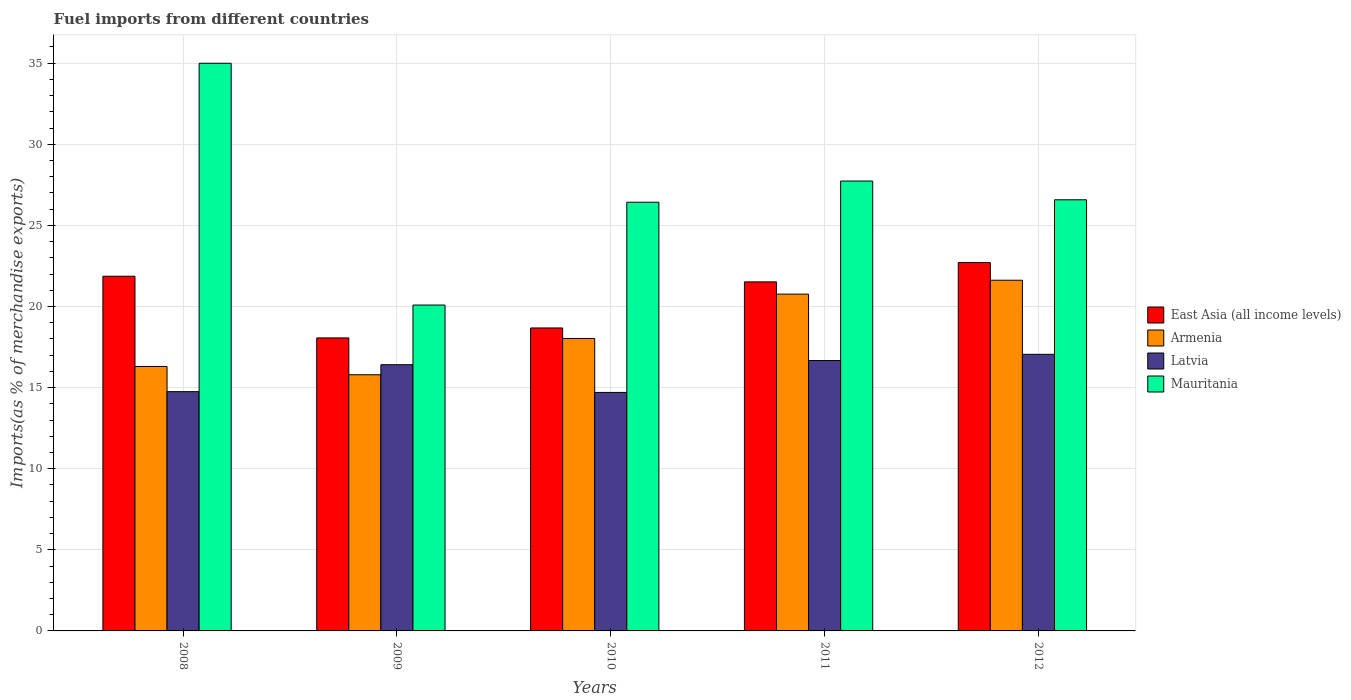How many different coloured bars are there?
Provide a succinct answer. 4. How many bars are there on the 3rd tick from the left?
Your answer should be compact. 4. What is the label of the 4th group of bars from the left?
Your answer should be very brief. 2011. What is the percentage of imports to different countries in Armenia in 2010?
Provide a short and direct response. 18.03. Across all years, what is the maximum percentage of imports to different countries in Latvia?
Your response must be concise. 17.05. Across all years, what is the minimum percentage of imports to different countries in Latvia?
Offer a very short reply. 14.7. In which year was the percentage of imports to different countries in Armenia minimum?
Ensure brevity in your answer.  2009. What is the total percentage of imports to different countries in Latvia in the graph?
Give a very brief answer. 79.58. What is the difference between the percentage of imports to different countries in Armenia in 2008 and that in 2011?
Offer a terse response. -4.46. What is the difference between the percentage of imports to different countries in Latvia in 2010 and the percentage of imports to different countries in Mauritania in 2012?
Offer a terse response. -11.87. What is the average percentage of imports to different countries in Latvia per year?
Your answer should be compact. 15.92. In the year 2012, what is the difference between the percentage of imports to different countries in Mauritania and percentage of imports to different countries in Armenia?
Provide a short and direct response. 4.96. What is the ratio of the percentage of imports to different countries in Latvia in 2009 to that in 2012?
Your answer should be compact. 0.96. Is the percentage of imports to different countries in East Asia (all income levels) in 2010 less than that in 2011?
Your answer should be compact. Yes. Is the difference between the percentage of imports to different countries in Mauritania in 2009 and 2010 greater than the difference between the percentage of imports to different countries in Armenia in 2009 and 2010?
Offer a terse response. No. What is the difference between the highest and the second highest percentage of imports to different countries in Latvia?
Your response must be concise. 0.39. What is the difference between the highest and the lowest percentage of imports to different countries in Armenia?
Make the answer very short. 5.83. Is the sum of the percentage of imports to different countries in Armenia in 2011 and 2012 greater than the maximum percentage of imports to different countries in Mauritania across all years?
Ensure brevity in your answer.  Yes. What does the 4th bar from the left in 2008 represents?
Offer a terse response. Mauritania. What does the 3rd bar from the right in 2012 represents?
Offer a very short reply. Armenia. Are all the bars in the graph horizontal?
Your answer should be compact. No. How many years are there in the graph?
Your response must be concise. 5. What is the difference between two consecutive major ticks on the Y-axis?
Offer a very short reply. 5. Are the values on the major ticks of Y-axis written in scientific E-notation?
Offer a very short reply. No. Does the graph contain any zero values?
Your response must be concise. No. How are the legend labels stacked?
Offer a terse response. Vertical. What is the title of the graph?
Your answer should be compact. Fuel imports from different countries. What is the label or title of the X-axis?
Your response must be concise. Years. What is the label or title of the Y-axis?
Provide a succinct answer. Imports(as % of merchandise exports). What is the Imports(as % of merchandise exports) of East Asia (all income levels) in 2008?
Keep it short and to the point. 21.87. What is the Imports(as % of merchandise exports) of Armenia in 2008?
Your answer should be compact. 16.3. What is the Imports(as % of merchandise exports) in Latvia in 2008?
Provide a succinct answer. 14.75. What is the Imports(as % of merchandise exports) of Mauritania in 2008?
Your answer should be very brief. 34.99. What is the Imports(as % of merchandise exports) of East Asia (all income levels) in 2009?
Offer a very short reply. 18.06. What is the Imports(as % of merchandise exports) of Armenia in 2009?
Your response must be concise. 15.79. What is the Imports(as % of merchandise exports) of Latvia in 2009?
Make the answer very short. 16.41. What is the Imports(as % of merchandise exports) in Mauritania in 2009?
Your answer should be very brief. 20.09. What is the Imports(as % of merchandise exports) in East Asia (all income levels) in 2010?
Keep it short and to the point. 18.68. What is the Imports(as % of merchandise exports) in Armenia in 2010?
Offer a terse response. 18.03. What is the Imports(as % of merchandise exports) of Latvia in 2010?
Make the answer very short. 14.7. What is the Imports(as % of merchandise exports) in Mauritania in 2010?
Offer a terse response. 26.43. What is the Imports(as % of merchandise exports) of East Asia (all income levels) in 2011?
Keep it short and to the point. 21.52. What is the Imports(as % of merchandise exports) in Armenia in 2011?
Provide a short and direct response. 20.76. What is the Imports(as % of merchandise exports) of Latvia in 2011?
Ensure brevity in your answer.  16.67. What is the Imports(as % of merchandise exports) of Mauritania in 2011?
Your answer should be compact. 27.73. What is the Imports(as % of merchandise exports) of East Asia (all income levels) in 2012?
Keep it short and to the point. 22.71. What is the Imports(as % of merchandise exports) of Armenia in 2012?
Your response must be concise. 21.62. What is the Imports(as % of merchandise exports) of Latvia in 2012?
Keep it short and to the point. 17.05. What is the Imports(as % of merchandise exports) in Mauritania in 2012?
Provide a short and direct response. 26.58. Across all years, what is the maximum Imports(as % of merchandise exports) in East Asia (all income levels)?
Make the answer very short. 22.71. Across all years, what is the maximum Imports(as % of merchandise exports) in Armenia?
Keep it short and to the point. 21.62. Across all years, what is the maximum Imports(as % of merchandise exports) of Latvia?
Offer a terse response. 17.05. Across all years, what is the maximum Imports(as % of merchandise exports) of Mauritania?
Your answer should be very brief. 34.99. Across all years, what is the minimum Imports(as % of merchandise exports) of East Asia (all income levels)?
Provide a short and direct response. 18.06. Across all years, what is the minimum Imports(as % of merchandise exports) of Armenia?
Keep it short and to the point. 15.79. Across all years, what is the minimum Imports(as % of merchandise exports) in Latvia?
Provide a short and direct response. 14.7. Across all years, what is the minimum Imports(as % of merchandise exports) of Mauritania?
Your response must be concise. 20.09. What is the total Imports(as % of merchandise exports) in East Asia (all income levels) in the graph?
Your answer should be very brief. 102.83. What is the total Imports(as % of merchandise exports) of Armenia in the graph?
Your answer should be compact. 92.5. What is the total Imports(as % of merchandise exports) in Latvia in the graph?
Your answer should be very brief. 79.58. What is the total Imports(as % of merchandise exports) in Mauritania in the graph?
Make the answer very short. 135.82. What is the difference between the Imports(as % of merchandise exports) in East Asia (all income levels) in 2008 and that in 2009?
Provide a short and direct response. 3.8. What is the difference between the Imports(as % of merchandise exports) of Armenia in 2008 and that in 2009?
Offer a terse response. 0.51. What is the difference between the Imports(as % of merchandise exports) in Latvia in 2008 and that in 2009?
Give a very brief answer. -1.66. What is the difference between the Imports(as % of merchandise exports) in Mauritania in 2008 and that in 2009?
Your answer should be very brief. 14.9. What is the difference between the Imports(as % of merchandise exports) in East Asia (all income levels) in 2008 and that in 2010?
Your answer should be compact. 3.19. What is the difference between the Imports(as % of merchandise exports) in Armenia in 2008 and that in 2010?
Give a very brief answer. -1.73. What is the difference between the Imports(as % of merchandise exports) of Latvia in 2008 and that in 2010?
Your answer should be compact. 0.05. What is the difference between the Imports(as % of merchandise exports) of Mauritania in 2008 and that in 2010?
Your answer should be compact. 8.57. What is the difference between the Imports(as % of merchandise exports) of East Asia (all income levels) in 2008 and that in 2011?
Make the answer very short. 0.35. What is the difference between the Imports(as % of merchandise exports) of Armenia in 2008 and that in 2011?
Give a very brief answer. -4.46. What is the difference between the Imports(as % of merchandise exports) in Latvia in 2008 and that in 2011?
Your answer should be very brief. -1.92. What is the difference between the Imports(as % of merchandise exports) of Mauritania in 2008 and that in 2011?
Ensure brevity in your answer.  7.26. What is the difference between the Imports(as % of merchandise exports) of East Asia (all income levels) in 2008 and that in 2012?
Provide a short and direct response. -0.84. What is the difference between the Imports(as % of merchandise exports) of Armenia in 2008 and that in 2012?
Your answer should be very brief. -5.32. What is the difference between the Imports(as % of merchandise exports) in Latvia in 2008 and that in 2012?
Keep it short and to the point. -2.3. What is the difference between the Imports(as % of merchandise exports) of Mauritania in 2008 and that in 2012?
Provide a short and direct response. 8.42. What is the difference between the Imports(as % of merchandise exports) in East Asia (all income levels) in 2009 and that in 2010?
Keep it short and to the point. -0.61. What is the difference between the Imports(as % of merchandise exports) in Armenia in 2009 and that in 2010?
Ensure brevity in your answer.  -2.24. What is the difference between the Imports(as % of merchandise exports) in Latvia in 2009 and that in 2010?
Keep it short and to the point. 1.71. What is the difference between the Imports(as % of merchandise exports) in Mauritania in 2009 and that in 2010?
Ensure brevity in your answer.  -6.34. What is the difference between the Imports(as % of merchandise exports) of East Asia (all income levels) in 2009 and that in 2011?
Give a very brief answer. -3.45. What is the difference between the Imports(as % of merchandise exports) of Armenia in 2009 and that in 2011?
Make the answer very short. -4.97. What is the difference between the Imports(as % of merchandise exports) in Latvia in 2009 and that in 2011?
Ensure brevity in your answer.  -0.26. What is the difference between the Imports(as % of merchandise exports) in Mauritania in 2009 and that in 2011?
Offer a terse response. -7.64. What is the difference between the Imports(as % of merchandise exports) of East Asia (all income levels) in 2009 and that in 2012?
Provide a short and direct response. -4.64. What is the difference between the Imports(as % of merchandise exports) in Armenia in 2009 and that in 2012?
Your response must be concise. -5.83. What is the difference between the Imports(as % of merchandise exports) in Latvia in 2009 and that in 2012?
Provide a succinct answer. -0.64. What is the difference between the Imports(as % of merchandise exports) of Mauritania in 2009 and that in 2012?
Ensure brevity in your answer.  -6.49. What is the difference between the Imports(as % of merchandise exports) of East Asia (all income levels) in 2010 and that in 2011?
Ensure brevity in your answer.  -2.84. What is the difference between the Imports(as % of merchandise exports) of Armenia in 2010 and that in 2011?
Make the answer very short. -2.73. What is the difference between the Imports(as % of merchandise exports) of Latvia in 2010 and that in 2011?
Make the answer very short. -1.96. What is the difference between the Imports(as % of merchandise exports) of Mauritania in 2010 and that in 2011?
Offer a terse response. -1.31. What is the difference between the Imports(as % of merchandise exports) in East Asia (all income levels) in 2010 and that in 2012?
Your answer should be very brief. -4.03. What is the difference between the Imports(as % of merchandise exports) of Armenia in 2010 and that in 2012?
Your answer should be very brief. -3.59. What is the difference between the Imports(as % of merchandise exports) in Latvia in 2010 and that in 2012?
Make the answer very short. -2.35. What is the difference between the Imports(as % of merchandise exports) in Mauritania in 2010 and that in 2012?
Ensure brevity in your answer.  -0.15. What is the difference between the Imports(as % of merchandise exports) in East Asia (all income levels) in 2011 and that in 2012?
Provide a short and direct response. -1.19. What is the difference between the Imports(as % of merchandise exports) in Armenia in 2011 and that in 2012?
Make the answer very short. -0.86. What is the difference between the Imports(as % of merchandise exports) in Latvia in 2011 and that in 2012?
Offer a terse response. -0.39. What is the difference between the Imports(as % of merchandise exports) in Mauritania in 2011 and that in 2012?
Offer a very short reply. 1.16. What is the difference between the Imports(as % of merchandise exports) of East Asia (all income levels) in 2008 and the Imports(as % of merchandise exports) of Armenia in 2009?
Give a very brief answer. 6.07. What is the difference between the Imports(as % of merchandise exports) of East Asia (all income levels) in 2008 and the Imports(as % of merchandise exports) of Latvia in 2009?
Provide a short and direct response. 5.45. What is the difference between the Imports(as % of merchandise exports) of East Asia (all income levels) in 2008 and the Imports(as % of merchandise exports) of Mauritania in 2009?
Your answer should be very brief. 1.78. What is the difference between the Imports(as % of merchandise exports) in Armenia in 2008 and the Imports(as % of merchandise exports) in Latvia in 2009?
Keep it short and to the point. -0.11. What is the difference between the Imports(as % of merchandise exports) of Armenia in 2008 and the Imports(as % of merchandise exports) of Mauritania in 2009?
Offer a terse response. -3.79. What is the difference between the Imports(as % of merchandise exports) of Latvia in 2008 and the Imports(as % of merchandise exports) of Mauritania in 2009?
Offer a terse response. -5.34. What is the difference between the Imports(as % of merchandise exports) of East Asia (all income levels) in 2008 and the Imports(as % of merchandise exports) of Armenia in 2010?
Offer a very short reply. 3.84. What is the difference between the Imports(as % of merchandise exports) in East Asia (all income levels) in 2008 and the Imports(as % of merchandise exports) in Latvia in 2010?
Your answer should be compact. 7.16. What is the difference between the Imports(as % of merchandise exports) in East Asia (all income levels) in 2008 and the Imports(as % of merchandise exports) in Mauritania in 2010?
Provide a succinct answer. -4.56. What is the difference between the Imports(as % of merchandise exports) of Armenia in 2008 and the Imports(as % of merchandise exports) of Latvia in 2010?
Your response must be concise. 1.6. What is the difference between the Imports(as % of merchandise exports) in Armenia in 2008 and the Imports(as % of merchandise exports) in Mauritania in 2010?
Offer a terse response. -10.13. What is the difference between the Imports(as % of merchandise exports) of Latvia in 2008 and the Imports(as % of merchandise exports) of Mauritania in 2010?
Keep it short and to the point. -11.68. What is the difference between the Imports(as % of merchandise exports) of East Asia (all income levels) in 2008 and the Imports(as % of merchandise exports) of Armenia in 2011?
Provide a succinct answer. 1.1. What is the difference between the Imports(as % of merchandise exports) of East Asia (all income levels) in 2008 and the Imports(as % of merchandise exports) of Latvia in 2011?
Ensure brevity in your answer.  5.2. What is the difference between the Imports(as % of merchandise exports) in East Asia (all income levels) in 2008 and the Imports(as % of merchandise exports) in Mauritania in 2011?
Your answer should be very brief. -5.87. What is the difference between the Imports(as % of merchandise exports) of Armenia in 2008 and the Imports(as % of merchandise exports) of Latvia in 2011?
Offer a very short reply. -0.36. What is the difference between the Imports(as % of merchandise exports) of Armenia in 2008 and the Imports(as % of merchandise exports) of Mauritania in 2011?
Offer a terse response. -11.43. What is the difference between the Imports(as % of merchandise exports) in Latvia in 2008 and the Imports(as % of merchandise exports) in Mauritania in 2011?
Your answer should be very brief. -12.98. What is the difference between the Imports(as % of merchandise exports) of East Asia (all income levels) in 2008 and the Imports(as % of merchandise exports) of Armenia in 2012?
Keep it short and to the point. 0.25. What is the difference between the Imports(as % of merchandise exports) in East Asia (all income levels) in 2008 and the Imports(as % of merchandise exports) in Latvia in 2012?
Offer a very short reply. 4.81. What is the difference between the Imports(as % of merchandise exports) of East Asia (all income levels) in 2008 and the Imports(as % of merchandise exports) of Mauritania in 2012?
Offer a terse response. -4.71. What is the difference between the Imports(as % of merchandise exports) of Armenia in 2008 and the Imports(as % of merchandise exports) of Latvia in 2012?
Provide a short and direct response. -0.75. What is the difference between the Imports(as % of merchandise exports) of Armenia in 2008 and the Imports(as % of merchandise exports) of Mauritania in 2012?
Make the answer very short. -10.28. What is the difference between the Imports(as % of merchandise exports) in Latvia in 2008 and the Imports(as % of merchandise exports) in Mauritania in 2012?
Offer a very short reply. -11.83. What is the difference between the Imports(as % of merchandise exports) of East Asia (all income levels) in 2009 and the Imports(as % of merchandise exports) of Armenia in 2010?
Offer a terse response. 0.03. What is the difference between the Imports(as % of merchandise exports) of East Asia (all income levels) in 2009 and the Imports(as % of merchandise exports) of Latvia in 2010?
Provide a short and direct response. 3.36. What is the difference between the Imports(as % of merchandise exports) of East Asia (all income levels) in 2009 and the Imports(as % of merchandise exports) of Mauritania in 2010?
Your answer should be very brief. -8.37. What is the difference between the Imports(as % of merchandise exports) of Armenia in 2009 and the Imports(as % of merchandise exports) of Latvia in 2010?
Provide a succinct answer. 1.09. What is the difference between the Imports(as % of merchandise exports) in Armenia in 2009 and the Imports(as % of merchandise exports) in Mauritania in 2010?
Ensure brevity in your answer.  -10.64. What is the difference between the Imports(as % of merchandise exports) in Latvia in 2009 and the Imports(as % of merchandise exports) in Mauritania in 2010?
Offer a very short reply. -10.02. What is the difference between the Imports(as % of merchandise exports) of East Asia (all income levels) in 2009 and the Imports(as % of merchandise exports) of Armenia in 2011?
Make the answer very short. -2.7. What is the difference between the Imports(as % of merchandise exports) in East Asia (all income levels) in 2009 and the Imports(as % of merchandise exports) in Latvia in 2011?
Ensure brevity in your answer.  1.4. What is the difference between the Imports(as % of merchandise exports) of East Asia (all income levels) in 2009 and the Imports(as % of merchandise exports) of Mauritania in 2011?
Offer a very short reply. -9.67. What is the difference between the Imports(as % of merchandise exports) in Armenia in 2009 and the Imports(as % of merchandise exports) in Latvia in 2011?
Ensure brevity in your answer.  -0.88. What is the difference between the Imports(as % of merchandise exports) of Armenia in 2009 and the Imports(as % of merchandise exports) of Mauritania in 2011?
Keep it short and to the point. -11.94. What is the difference between the Imports(as % of merchandise exports) in Latvia in 2009 and the Imports(as % of merchandise exports) in Mauritania in 2011?
Your response must be concise. -11.32. What is the difference between the Imports(as % of merchandise exports) in East Asia (all income levels) in 2009 and the Imports(as % of merchandise exports) in Armenia in 2012?
Your response must be concise. -3.56. What is the difference between the Imports(as % of merchandise exports) in East Asia (all income levels) in 2009 and the Imports(as % of merchandise exports) in Latvia in 2012?
Make the answer very short. 1.01. What is the difference between the Imports(as % of merchandise exports) of East Asia (all income levels) in 2009 and the Imports(as % of merchandise exports) of Mauritania in 2012?
Your answer should be compact. -8.52. What is the difference between the Imports(as % of merchandise exports) in Armenia in 2009 and the Imports(as % of merchandise exports) in Latvia in 2012?
Provide a succinct answer. -1.26. What is the difference between the Imports(as % of merchandise exports) of Armenia in 2009 and the Imports(as % of merchandise exports) of Mauritania in 2012?
Make the answer very short. -10.79. What is the difference between the Imports(as % of merchandise exports) in Latvia in 2009 and the Imports(as % of merchandise exports) in Mauritania in 2012?
Provide a succinct answer. -10.17. What is the difference between the Imports(as % of merchandise exports) in East Asia (all income levels) in 2010 and the Imports(as % of merchandise exports) in Armenia in 2011?
Your answer should be very brief. -2.09. What is the difference between the Imports(as % of merchandise exports) of East Asia (all income levels) in 2010 and the Imports(as % of merchandise exports) of Latvia in 2011?
Keep it short and to the point. 2.01. What is the difference between the Imports(as % of merchandise exports) of East Asia (all income levels) in 2010 and the Imports(as % of merchandise exports) of Mauritania in 2011?
Offer a very short reply. -9.06. What is the difference between the Imports(as % of merchandise exports) of Armenia in 2010 and the Imports(as % of merchandise exports) of Latvia in 2011?
Provide a short and direct response. 1.36. What is the difference between the Imports(as % of merchandise exports) of Armenia in 2010 and the Imports(as % of merchandise exports) of Mauritania in 2011?
Ensure brevity in your answer.  -9.7. What is the difference between the Imports(as % of merchandise exports) of Latvia in 2010 and the Imports(as % of merchandise exports) of Mauritania in 2011?
Make the answer very short. -13.03. What is the difference between the Imports(as % of merchandise exports) in East Asia (all income levels) in 2010 and the Imports(as % of merchandise exports) in Armenia in 2012?
Your answer should be very brief. -2.94. What is the difference between the Imports(as % of merchandise exports) in East Asia (all income levels) in 2010 and the Imports(as % of merchandise exports) in Latvia in 2012?
Offer a terse response. 1.62. What is the difference between the Imports(as % of merchandise exports) in East Asia (all income levels) in 2010 and the Imports(as % of merchandise exports) in Mauritania in 2012?
Make the answer very short. -7.9. What is the difference between the Imports(as % of merchandise exports) of Armenia in 2010 and the Imports(as % of merchandise exports) of Latvia in 2012?
Offer a very short reply. 0.98. What is the difference between the Imports(as % of merchandise exports) of Armenia in 2010 and the Imports(as % of merchandise exports) of Mauritania in 2012?
Offer a very short reply. -8.55. What is the difference between the Imports(as % of merchandise exports) in Latvia in 2010 and the Imports(as % of merchandise exports) in Mauritania in 2012?
Provide a succinct answer. -11.87. What is the difference between the Imports(as % of merchandise exports) of East Asia (all income levels) in 2011 and the Imports(as % of merchandise exports) of Armenia in 2012?
Make the answer very short. -0.1. What is the difference between the Imports(as % of merchandise exports) of East Asia (all income levels) in 2011 and the Imports(as % of merchandise exports) of Latvia in 2012?
Your answer should be very brief. 4.46. What is the difference between the Imports(as % of merchandise exports) of East Asia (all income levels) in 2011 and the Imports(as % of merchandise exports) of Mauritania in 2012?
Provide a succinct answer. -5.06. What is the difference between the Imports(as % of merchandise exports) in Armenia in 2011 and the Imports(as % of merchandise exports) in Latvia in 2012?
Give a very brief answer. 3.71. What is the difference between the Imports(as % of merchandise exports) in Armenia in 2011 and the Imports(as % of merchandise exports) in Mauritania in 2012?
Offer a terse response. -5.81. What is the difference between the Imports(as % of merchandise exports) of Latvia in 2011 and the Imports(as % of merchandise exports) of Mauritania in 2012?
Your answer should be very brief. -9.91. What is the average Imports(as % of merchandise exports) of East Asia (all income levels) per year?
Offer a very short reply. 20.57. What is the average Imports(as % of merchandise exports) in Armenia per year?
Provide a short and direct response. 18.5. What is the average Imports(as % of merchandise exports) of Latvia per year?
Make the answer very short. 15.92. What is the average Imports(as % of merchandise exports) of Mauritania per year?
Offer a very short reply. 27.16. In the year 2008, what is the difference between the Imports(as % of merchandise exports) of East Asia (all income levels) and Imports(as % of merchandise exports) of Armenia?
Make the answer very short. 5.56. In the year 2008, what is the difference between the Imports(as % of merchandise exports) of East Asia (all income levels) and Imports(as % of merchandise exports) of Latvia?
Provide a succinct answer. 7.12. In the year 2008, what is the difference between the Imports(as % of merchandise exports) in East Asia (all income levels) and Imports(as % of merchandise exports) in Mauritania?
Provide a short and direct response. -13.13. In the year 2008, what is the difference between the Imports(as % of merchandise exports) in Armenia and Imports(as % of merchandise exports) in Latvia?
Keep it short and to the point. 1.55. In the year 2008, what is the difference between the Imports(as % of merchandise exports) in Armenia and Imports(as % of merchandise exports) in Mauritania?
Your response must be concise. -18.69. In the year 2008, what is the difference between the Imports(as % of merchandise exports) in Latvia and Imports(as % of merchandise exports) in Mauritania?
Provide a short and direct response. -20.24. In the year 2009, what is the difference between the Imports(as % of merchandise exports) of East Asia (all income levels) and Imports(as % of merchandise exports) of Armenia?
Provide a succinct answer. 2.27. In the year 2009, what is the difference between the Imports(as % of merchandise exports) in East Asia (all income levels) and Imports(as % of merchandise exports) in Latvia?
Your answer should be very brief. 1.65. In the year 2009, what is the difference between the Imports(as % of merchandise exports) in East Asia (all income levels) and Imports(as % of merchandise exports) in Mauritania?
Your response must be concise. -2.03. In the year 2009, what is the difference between the Imports(as % of merchandise exports) of Armenia and Imports(as % of merchandise exports) of Latvia?
Keep it short and to the point. -0.62. In the year 2009, what is the difference between the Imports(as % of merchandise exports) of Armenia and Imports(as % of merchandise exports) of Mauritania?
Your answer should be very brief. -4.3. In the year 2009, what is the difference between the Imports(as % of merchandise exports) in Latvia and Imports(as % of merchandise exports) in Mauritania?
Provide a short and direct response. -3.68. In the year 2010, what is the difference between the Imports(as % of merchandise exports) of East Asia (all income levels) and Imports(as % of merchandise exports) of Armenia?
Offer a terse response. 0.65. In the year 2010, what is the difference between the Imports(as % of merchandise exports) of East Asia (all income levels) and Imports(as % of merchandise exports) of Latvia?
Provide a succinct answer. 3.97. In the year 2010, what is the difference between the Imports(as % of merchandise exports) of East Asia (all income levels) and Imports(as % of merchandise exports) of Mauritania?
Offer a very short reply. -7.75. In the year 2010, what is the difference between the Imports(as % of merchandise exports) in Armenia and Imports(as % of merchandise exports) in Latvia?
Offer a very short reply. 3.33. In the year 2010, what is the difference between the Imports(as % of merchandise exports) of Armenia and Imports(as % of merchandise exports) of Mauritania?
Ensure brevity in your answer.  -8.4. In the year 2010, what is the difference between the Imports(as % of merchandise exports) in Latvia and Imports(as % of merchandise exports) in Mauritania?
Keep it short and to the point. -11.72. In the year 2011, what is the difference between the Imports(as % of merchandise exports) in East Asia (all income levels) and Imports(as % of merchandise exports) in Armenia?
Give a very brief answer. 0.75. In the year 2011, what is the difference between the Imports(as % of merchandise exports) of East Asia (all income levels) and Imports(as % of merchandise exports) of Latvia?
Your answer should be very brief. 4.85. In the year 2011, what is the difference between the Imports(as % of merchandise exports) in East Asia (all income levels) and Imports(as % of merchandise exports) in Mauritania?
Ensure brevity in your answer.  -6.22. In the year 2011, what is the difference between the Imports(as % of merchandise exports) of Armenia and Imports(as % of merchandise exports) of Latvia?
Make the answer very short. 4.1. In the year 2011, what is the difference between the Imports(as % of merchandise exports) of Armenia and Imports(as % of merchandise exports) of Mauritania?
Make the answer very short. -6.97. In the year 2011, what is the difference between the Imports(as % of merchandise exports) of Latvia and Imports(as % of merchandise exports) of Mauritania?
Provide a short and direct response. -11.07. In the year 2012, what is the difference between the Imports(as % of merchandise exports) in East Asia (all income levels) and Imports(as % of merchandise exports) in Armenia?
Your response must be concise. 1.09. In the year 2012, what is the difference between the Imports(as % of merchandise exports) of East Asia (all income levels) and Imports(as % of merchandise exports) of Latvia?
Give a very brief answer. 5.65. In the year 2012, what is the difference between the Imports(as % of merchandise exports) in East Asia (all income levels) and Imports(as % of merchandise exports) in Mauritania?
Offer a very short reply. -3.87. In the year 2012, what is the difference between the Imports(as % of merchandise exports) in Armenia and Imports(as % of merchandise exports) in Latvia?
Give a very brief answer. 4.57. In the year 2012, what is the difference between the Imports(as % of merchandise exports) of Armenia and Imports(as % of merchandise exports) of Mauritania?
Offer a very short reply. -4.96. In the year 2012, what is the difference between the Imports(as % of merchandise exports) of Latvia and Imports(as % of merchandise exports) of Mauritania?
Your response must be concise. -9.52. What is the ratio of the Imports(as % of merchandise exports) in East Asia (all income levels) in 2008 to that in 2009?
Ensure brevity in your answer.  1.21. What is the ratio of the Imports(as % of merchandise exports) in Armenia in 2008 to that in 2009?
Offer a terse response. 1.03. What is the ratio of the Imports(as % of merchandise exports) in Latvia in 2008 to that in 2009?
Offer a terse response. 0.9. What is the ratio of the Imports(as % of merchandise exports) in Mauritania in 2008 to that in 2009?
Make the answer very short. 1.74. What is the ratio of the Imports(as % of merchandise exports) in East Asia (all income levels) in 2008 to that in 2010?
Keep it short and to the point. 1.17. What is the ratio of the Imports(as % of merchandise exports) in Armenia in 2008 to that in 2010?
Give a very brief answer. 0.9. What is the ratio of the Imports(as % of merchandise exports) of Mauritania in 2008 to that in 2010?
Keep it short and to the point. 1.32. What is the ratio of the Imports(as % of merchandise exports) in East Asia (all income levels) in 2008 to that in 2011?
Your answer should be very brief. 1.02. What is the ratio of the Imports(as % of merchandise exports) of Armenia in 2008 to that in 2011?
Provide a short and direct response. 0.79. What is the ratio of the Imports(as % of merchandise exports) in Latvia in 2008 to that in 2011?
Provide a short and direct response. 0.89. What is the ratio of the Imports(as % of merchandise exports) in Mauritania in 2008 to that in 2011?
Keep it short and to the point. 1.26. What is the ratio of the Imports(as % of merchandise exports) of East Asia (all income levels) in 2008 to that in 2012?
Offer a very short reply. 0.96. What is the ratio of the Imports(as % of merchandise exports) in Armenia in 2008 to that in 2012?
Keep it short and to the point. 0.75. What is the ratio of the Imports(as % of merchandise exports) of Latvia in 2008 to that in 2012?
Offer a terse response. 0.86. What is the ratio of the Imports(as % of merchandise exports) in Mauritania in 2008 to that in 2012?
Your answer should be very brief. 1.32. What is the ratio of the Imports(as % of merchandise exports) of East Asia (all income levels) in 2009 to that in 2010?
Provide a succinct answer. 0.97. What is the ratio of the Imports(as % of merchandise exports) of Armenia in 2009 to that in 2010?
Make the answer very short. 0.88. What is the ratio of the Imports(as % of merchandise exports) in Latvia in 2009 to that in 2010?
Your response must be concise. 1.12. What is the ratio of the Imports(as % of merchandise exports) of Mauritania in 2009 to that in 2010?
Make the answer very short. 0.76. What is the ratio of the Imports(as % of merchandise exports) of East Asia (all income levels) in 2009 to that in 2011?
Give a very brief answer. 0.84. What is the ratio of the Imports(as % of merchandise exports) of Armenia in 2009 to that in 2011?
Offer a terse response. 0.76. What is the ratio of the Imports(as % of merchandise exports) in Latvia in 2009 to that in 2011?
Offer a very short reply. 0.98. What is the ratio of the Imports(as % of merchandise exports) in Mauritania in 2009 to that in 2011?
Ensure brevity in your answer.  0.72. What is the ratio of the Imports(as % of merchandise exports) in East Asia (all income levels) in 2009 to that in 2012?
Your answer should be very brief. 0.8. What is the ratio of the Imports(as % of merchandise exports) in Armenia in 2009 to that in 2012?
Provide a short and direct response. 0.73. What is the ratio of the Imports(as % of merchandise exports) of Latvia in 2009 to that in 2012?
Offer a very short reply. 0.96. What is the ratio of the Imports(as % of merchandise exports) of Mauritania in 2009 to that in 2012?
Your answer should be very brief. 0.76. What is the ratio of the Imports(as % of merchandise exports) of East Asia (all income levels) in 2010 to that in 2011?
Keep it short and to the point. 0.87. What is the ratio of the Imports(as % of merchandise exports) in Armenia in 2010 to that in 2011?
Offer a terse response. 0.87. What is the ratio of the Imports(as % of merchandise exports) in Latvia in 2010 to that in 2011?
Ensure brevity in your answer.  0.88. What is the ratio of the Imports(as % of merchandise exports) of Mauritania in 2010 to that in 2011?
Provide a succinct answer. 0.95. What is the ratio of the Imports(as % of merchandise exports) in East Asia (all income levels) in 2010 to that in 2012?
Your answer should be compact. 0.82. What is the ratio of the Imports(as % of merchandise exports) of Armenia in 2010 to that in 2012?
Ensure brevity in your answer.  0.83. What is the ratio of the Imports(as % of merchandise exports) of Latvia in 2010 to that in 2012?
Your answer should be compact. 0.86. What is the ratio of the Imports(as % of merchandise exports) in East Asia (all income levels) in 2011 to that in 2012?
Your answer should be very brief. 0.95. What is the ratio of the Imports(as % of merchandise exports) of Armenia in 2011 to that in 2012?
Provide a short and direct response. 0.96. What is the ratio of the Imports(as % of merchandise exports) of Latvia in 2011 to that in 2012?
Make the answer very short. 0.98. What is the ratio of the Imports(as % of merchandise exports) of Mauritania in 2011 to that in 2012?
Ensure brevity in your answer.  1.04. What is the difference between the highest and the second highest Imports(as % of merchandise exports) in East Asia (all income levels)?
Provide a succinct answer. 0.84. What is the difference between the highest and the second highest Imports(as % of merchandise exports) of Armenia?
Provide a succinct answer. 0.86. What is the difference between the highest and the second highest Imports(as % of merchandise exports) of Latvia?
Make the answer very short. 0.39. What is the difference between the highest and the second highest Imports(as % of merchandise exports) in Mauritania?
Offer a terse response. 7.26. What is the difference between the highest and the lowest Imports(as % of merchandise exports) in East Asia (all income levels)?
Your response must be concise. 4.64. What is the difference between the highest and the lowest Imports(as % of merchandise exports) of Armenia?
Offer a terse response. 5.83. What is the difference between the highest and the lowest Imports(as % of merchandise exports) in Latvia?
Your response must be concise. 2.35. What is the difference between the highest and the lowest Imports(as % of merchandise exports) in Mauritania?
Your response must be concise. 14.9. 